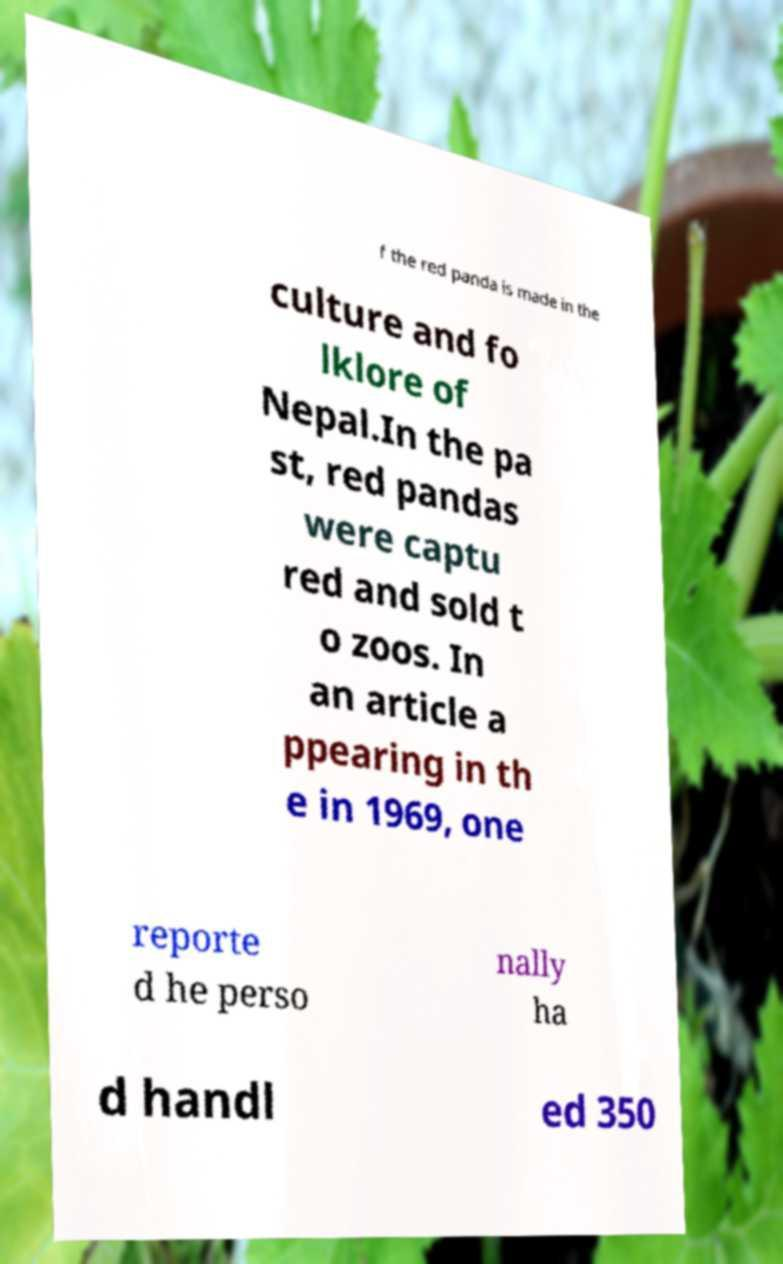Please read and relay the text visible in this image. What does it say? f the red panda is made in the culture and fo lklore of Nepal.In the pa st, red pandas were captu red and sold t o zoos. In an article a ppearing in th e in 1969, one reporte d he perso nally ha d handl ed 350 